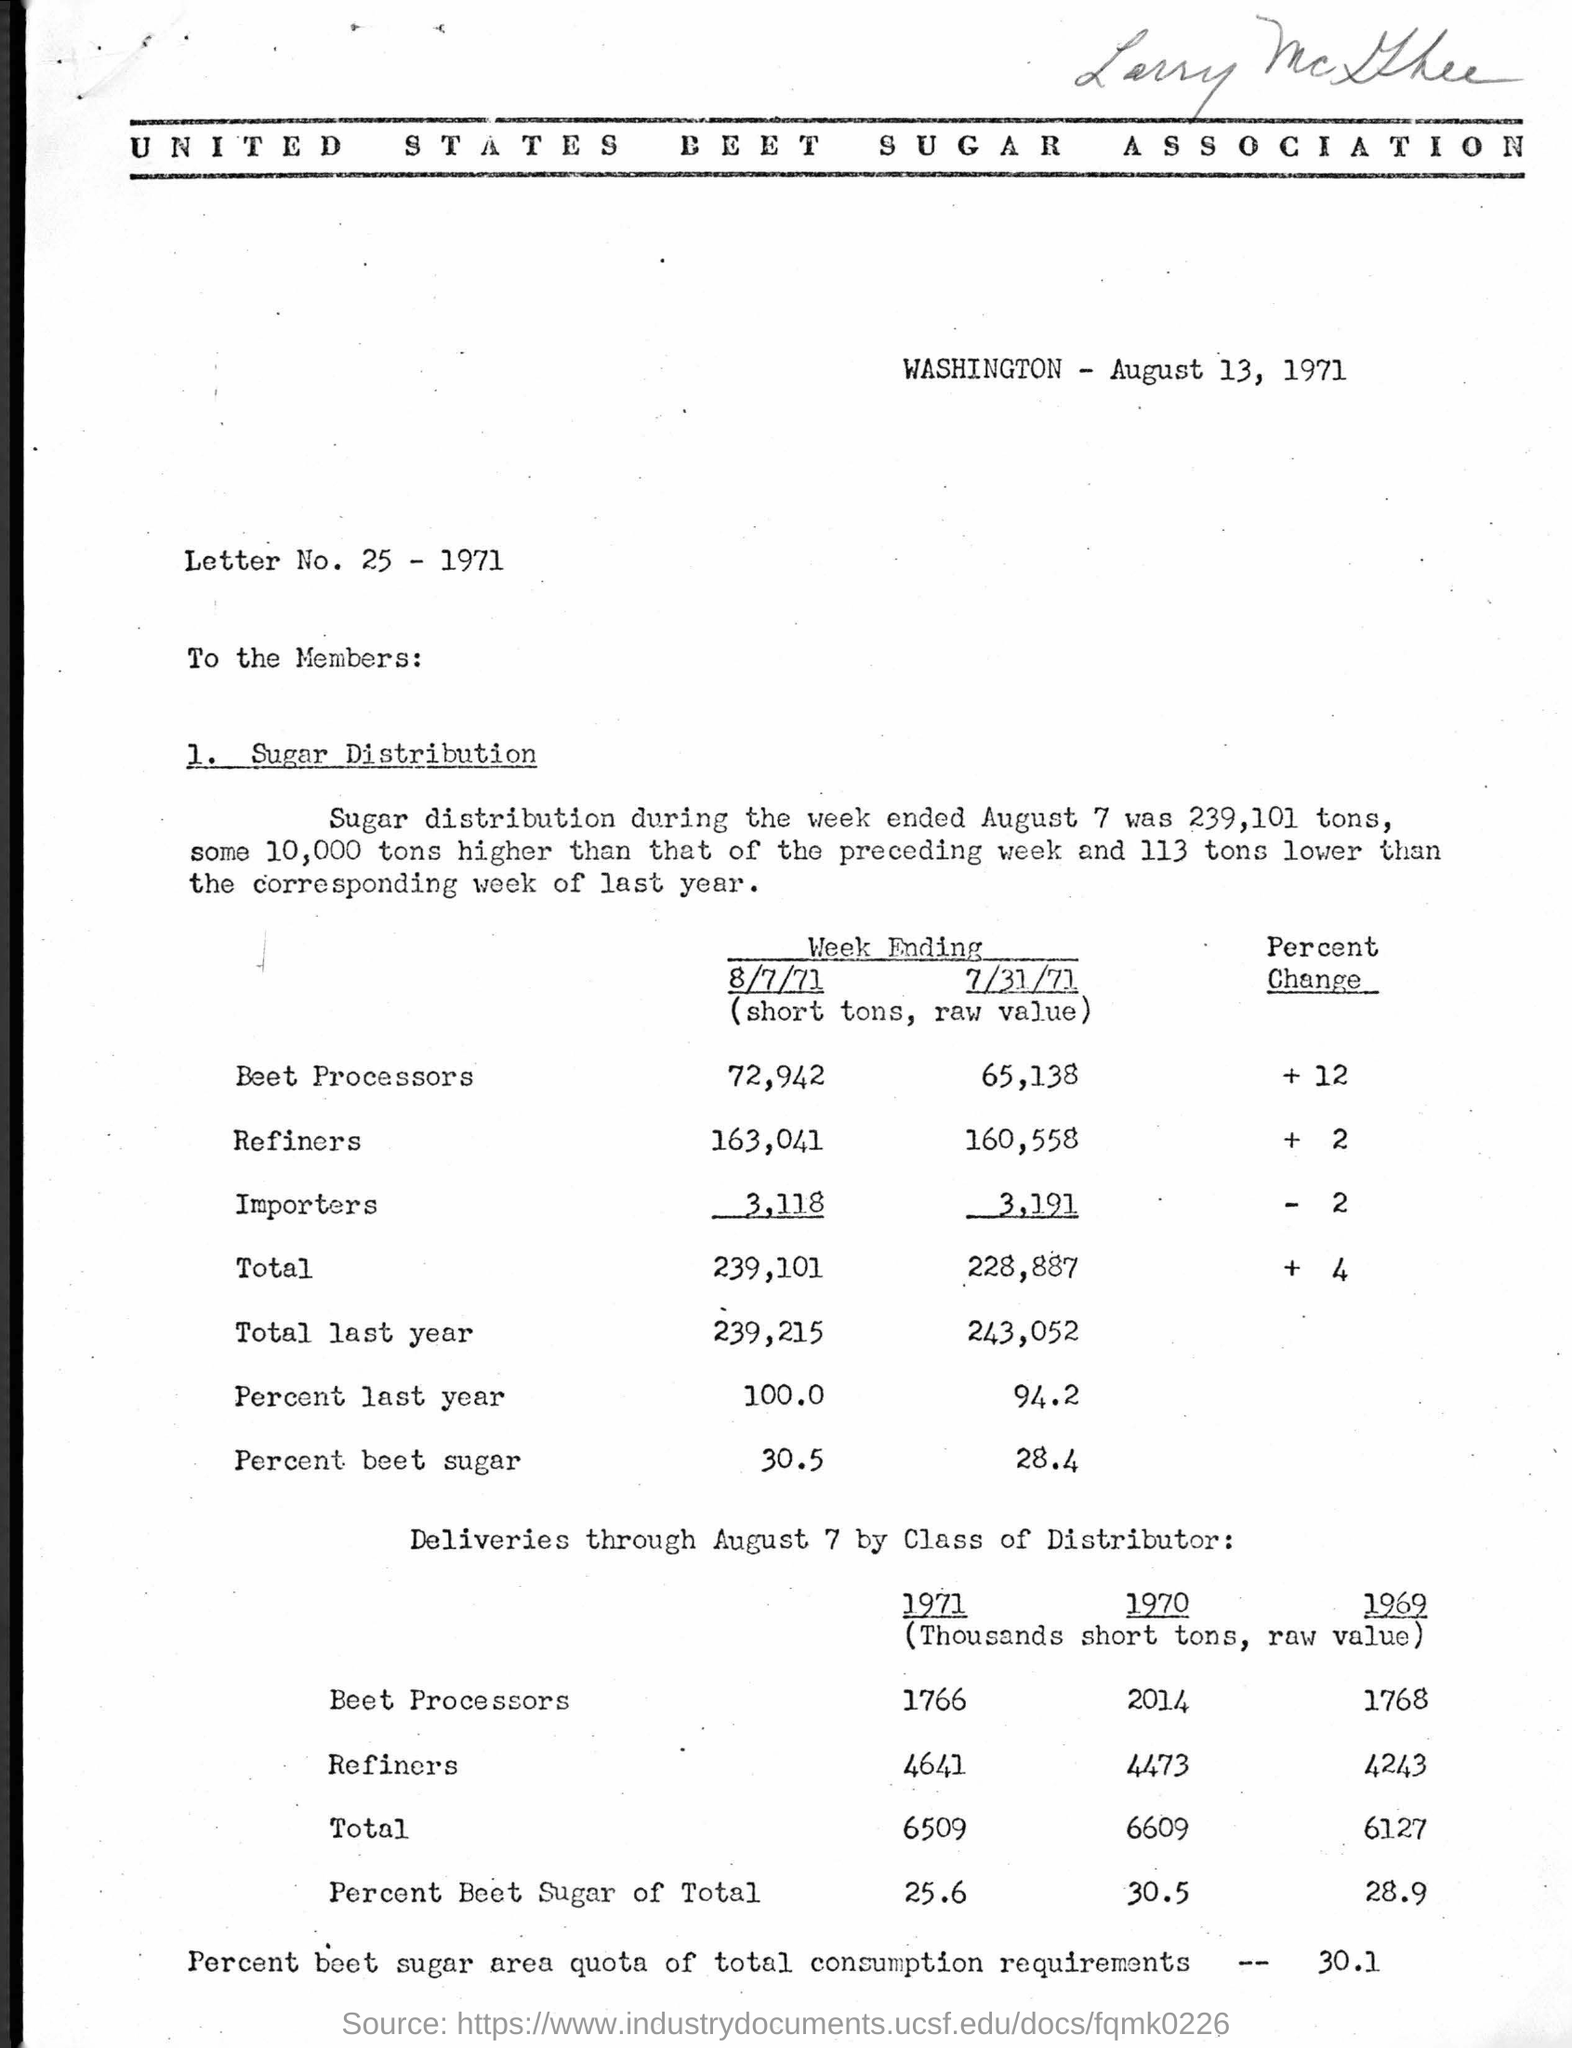Outline some significant characteristics in this image. The heading of the document is "UNITED STATES BEET SUGAR ASSOCIATION. The letter number written in the document is 25. 